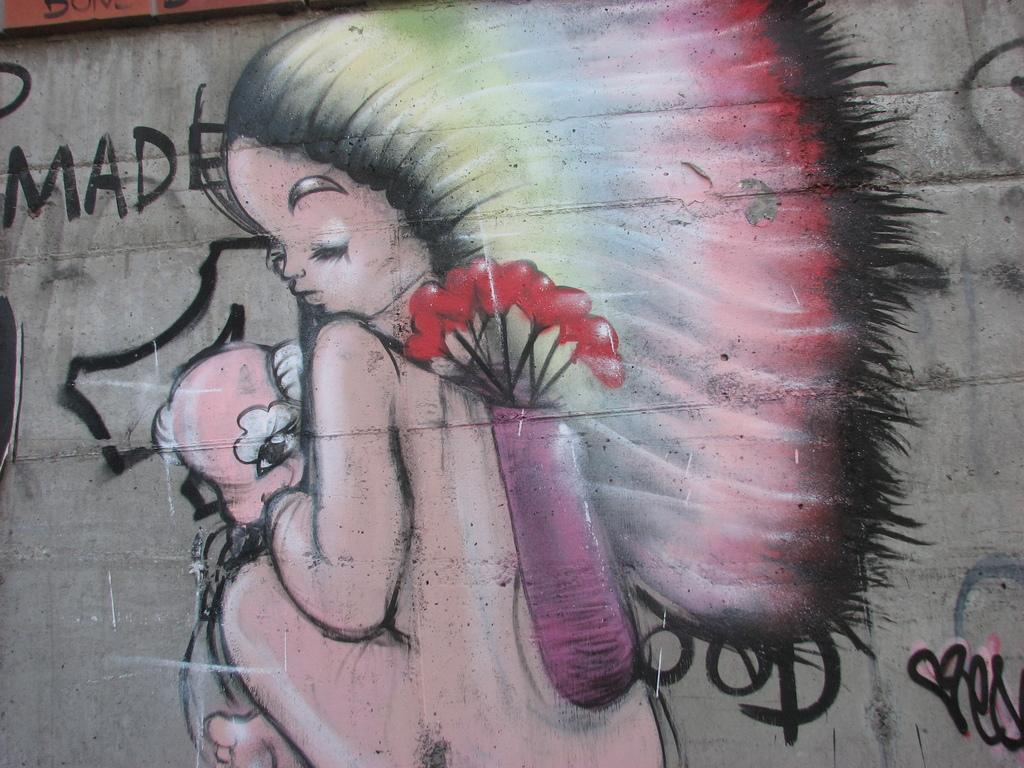What is depicted in the painting that is visible in the image? The painting contains a depiction of a woman. Where is the painting located in the image? The painting is on a wall. How would you classify the painting based on its style or context? The painting is a form of graffiti. What else can be seen on the wall in the image? There is text written on the wall. How many holes can be seen in the painting? There are no holes visible in the painting; it is a flat, two-dimensional image. 